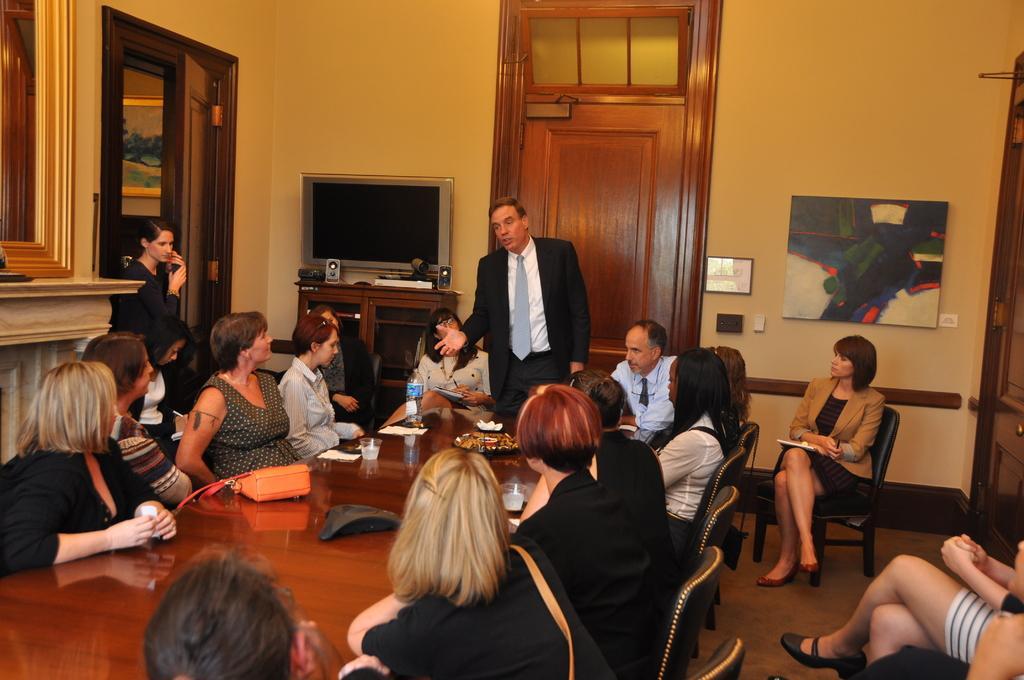Could you give a brief overview of what you see in this image? On the middle a man is standing and speaking, he wore tie, shirt, trouser. Many people are sitting around the table and listening to him. On the left side there is a television. In the middle there's the door. 